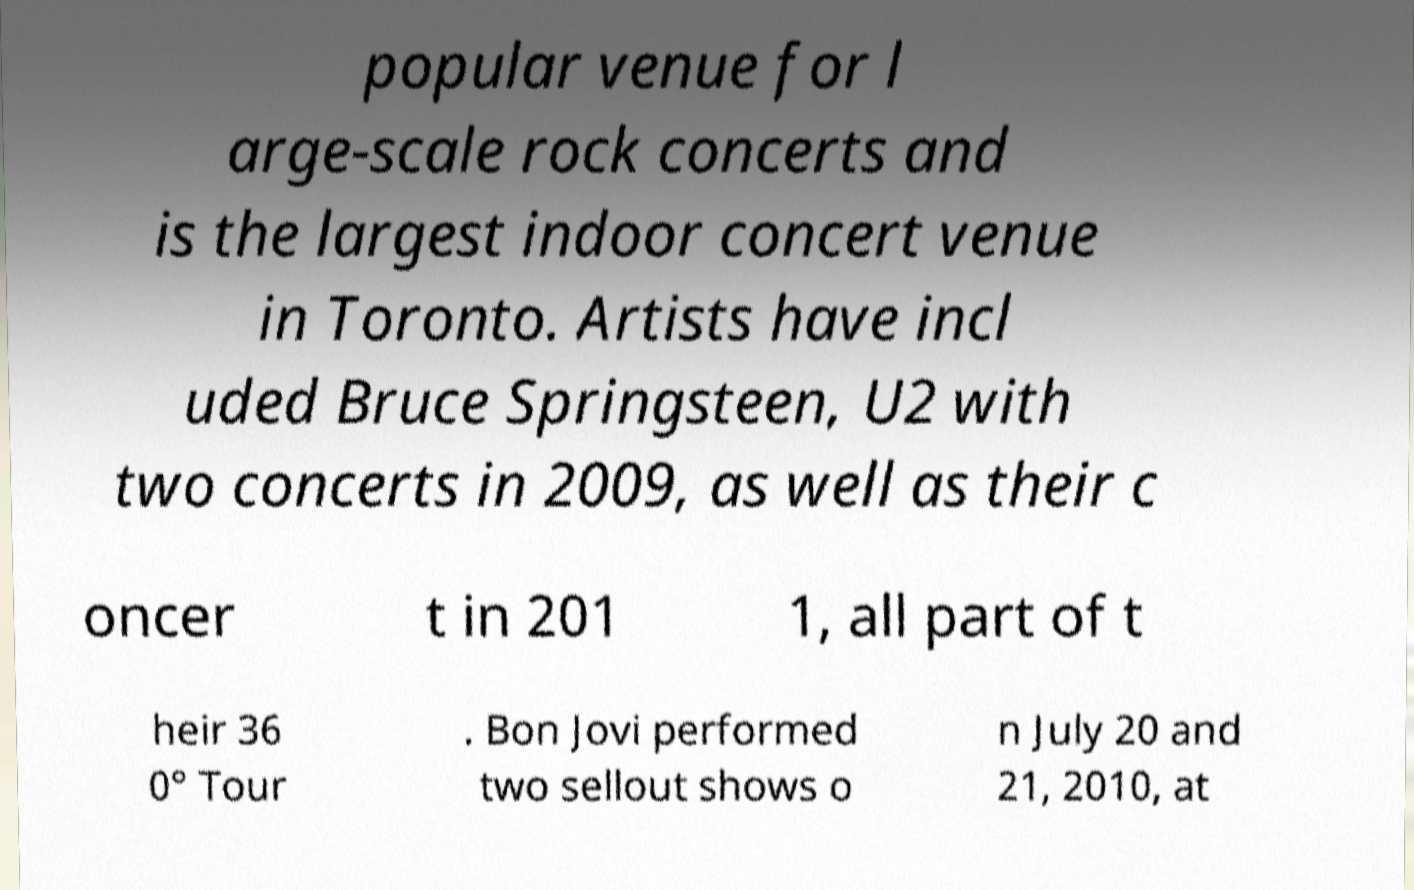I need the written content from this picture converted into text. Can you do that? popular venue for l arge-scale rock concerts and is the largest indoor concert venue in Toronto. Artists have incl uded Bruce Springsteen, U2 with two concerts in 2009, as well as their c oncer t in 201 1, all part of t heir 36 0° Tour . Bon Jovi performed two sellout shows o n July 20 and 21, 2010, at 